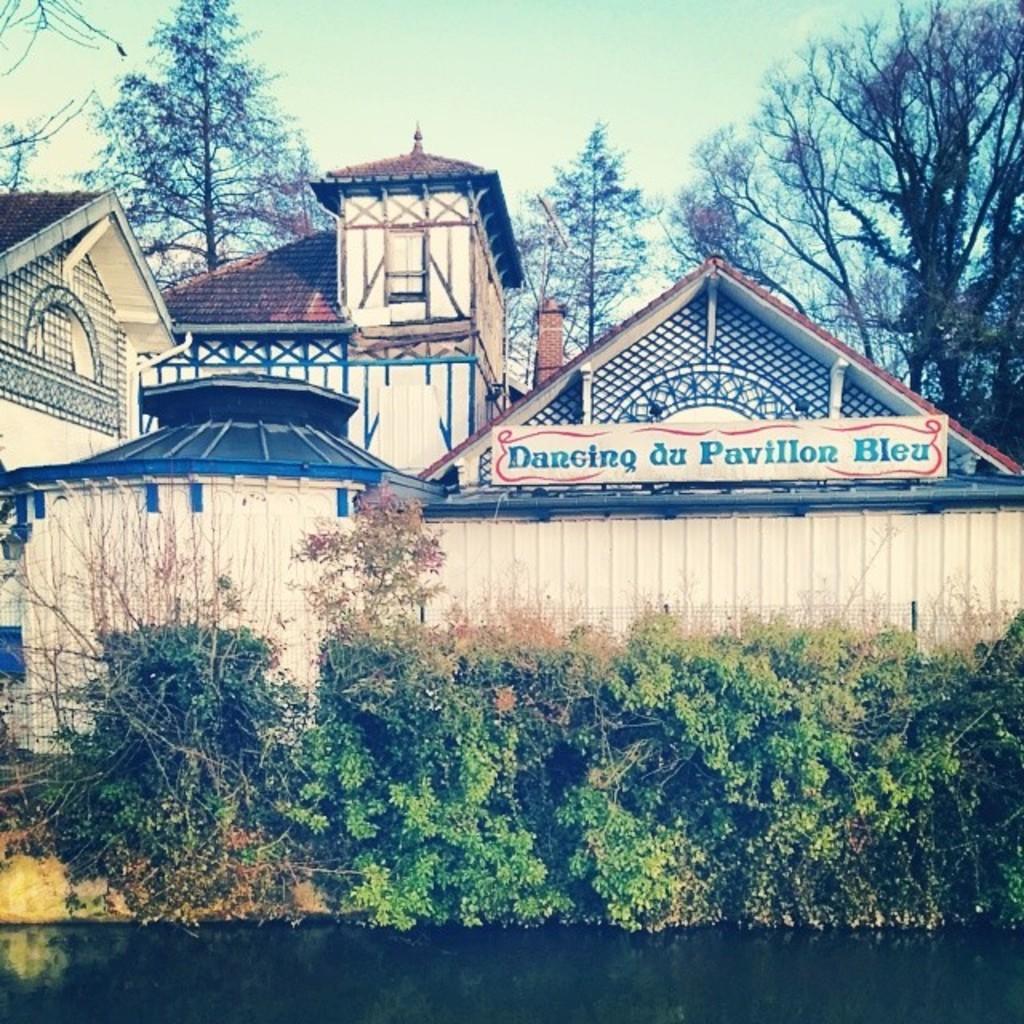Could you give a brief overview of what you see in this image? In this image I see the water, number of plants, fencing and I see number of buildings and I see a board over here on which there is something written. In the background I see number of trees and I see the sky. 